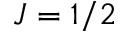Convert formula to latex. <formula><loc_0><loc_0><loc_500><loc_500>J = 1 / 2</formula> 